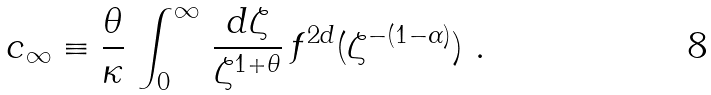<formula> <loc_0><loc_0><loc_500><loc_500>c _ { \infty } \equiv \frac { \theta } { \kappa } \, \int _ { 0 } ^ { \infty } \, \frac { d \zeta } { \zeta ^ { 1 + \theta } } \, f ^ { 2 d } ( \zeta ^ { - ( 1 - \alpha ) } ) \ .</formula> 